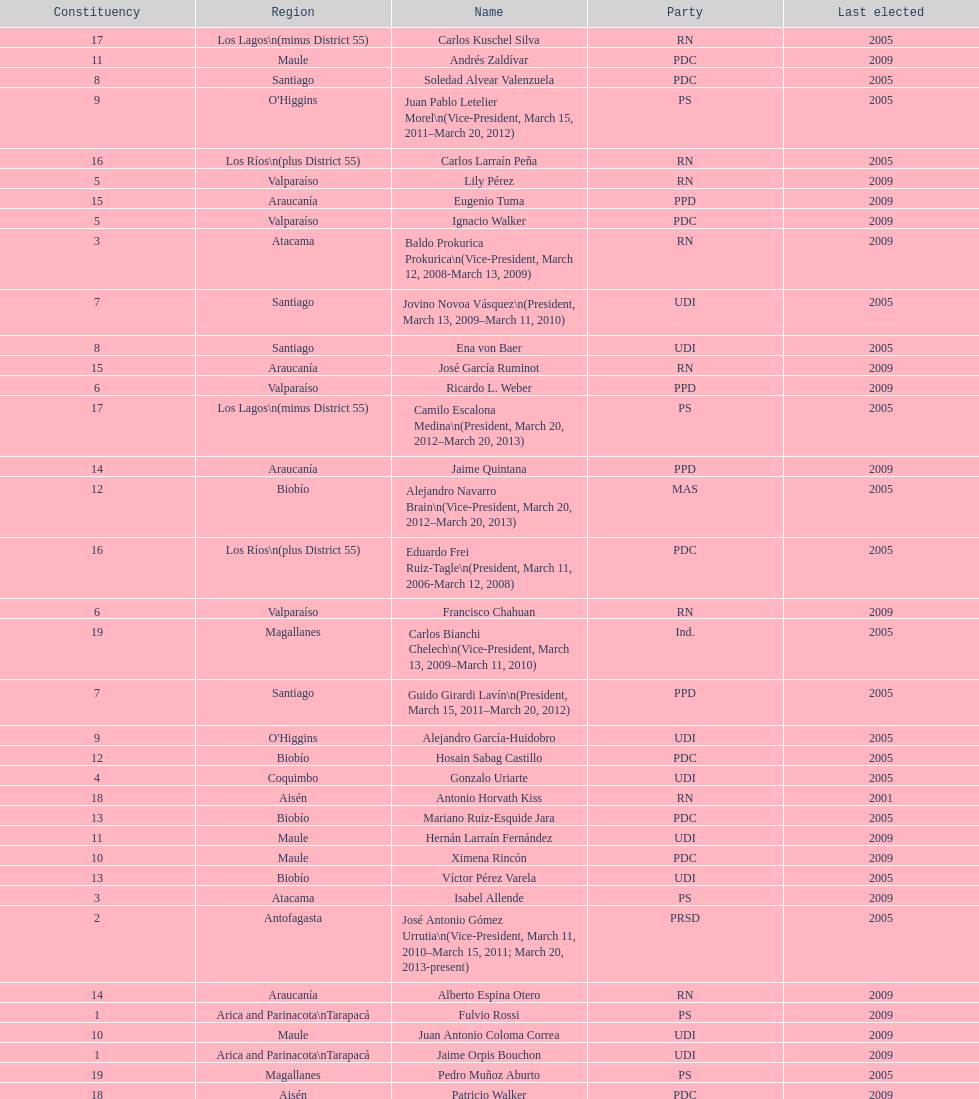What is the last region listed on the table? Magallanes. 